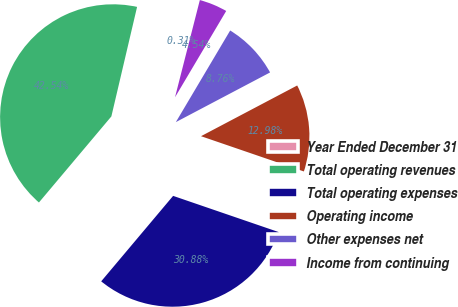Convert chart. <chart><loc_0><loc_0><loc_500><loc_500><pie_chart><fcel>Year Ended December 31<fcel>Total operating revenues<fcel>Total operating expenses<fcel>Operating income<fcel>Other expenses net<fcel>Income from continuing<nl><fcel>0.31%<fcel>42.54%<fcel>30.88%<fcel>12.98%<fcel>8.76%<fcel>4.54%<nl></chart> 